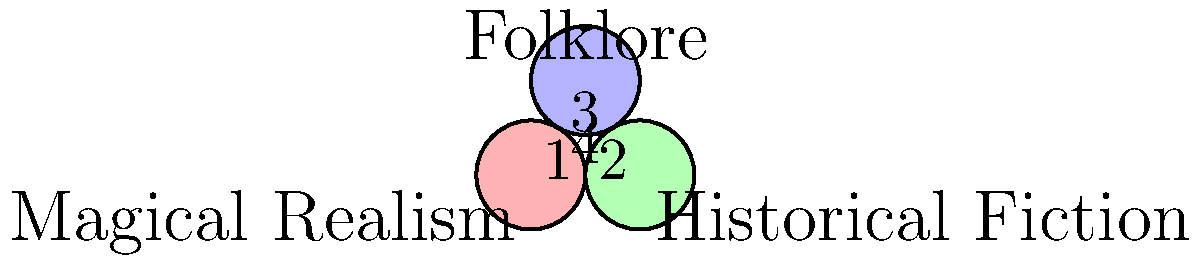In your role as a multilingual publishing professional, you're analyzing the overlap of literary genres across cultures. The Venn diagram depicts the intersection of Magical Realism, Historical Fiction, and Folklore. Which region represents works that incorporate elements from all three genres? To answer this question, let's analyze the Venn diagram step-by-step:

1. The diagram consists of three overlapping circles, each representing a literary genre:
   - Magical Realism
   - Historical Fiction
   - Folklore

2. The overlapping regions represent works that incorporate elements from multiple genres:
   - Region 1: Overlap between Magical Realism and Historical Fiction
   - Region 2: Overlap between Historical Fiction and Folklore
   - Region 3: Overlap between Magical Realism and Folklore

3. The central region, labeled "4," is where all three circles intersect.

4. This central region represents works that incorporate elements from all three genres simultaneously.

5. Therefore, region 4 is the area we're looking for, as it represents literary works that blend Magical Realism, Historical Fiction, and Folklore.

This intersection is particularly interesting in a multilingual publishing context, as it may represent works that cross cultural boundaries and blend various storytelling traditions.
Answer: Region 4 